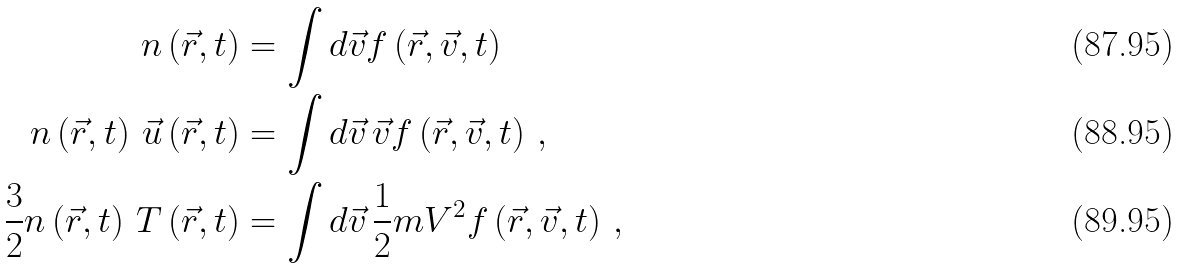<formula> <loc_0><loc_0><loc_500><loc_500>n \left ( \vec { r } , t \right ) & = \int d \vec { v } f \left ( \vec { r } , \vec { v } , t \right ) \\ n \left ( \vec { r } , t \right ) \, \vec { u } \left ( \vec { r } , t \right ) & = \int d \vec { v } \, \vec { v } f \left ( \vec { r } , \vec { v } , t \right ) \, , \\ \frac { 3 } { 2 } n \left ( \vec { r } , t \right ) \, T \left ( \vec { r } , t \right ) & = \int d \vec { v } \, \frac { 1 } { 2 } m V ^ { 2 } f \left ( \vec { r } , \vec { v } , t \right ) \, ,</formula> 